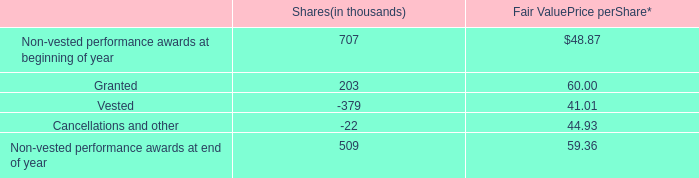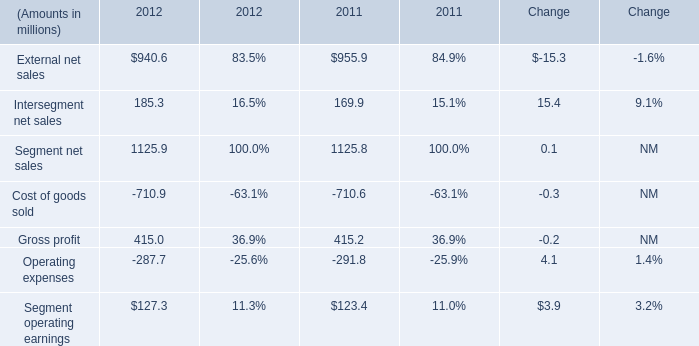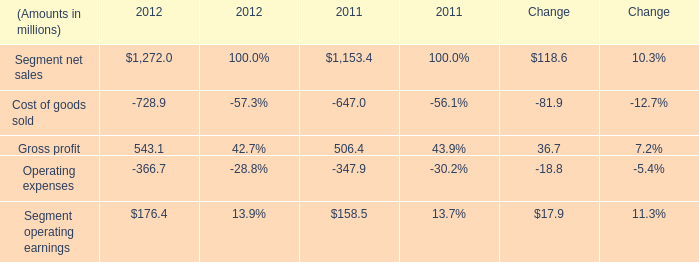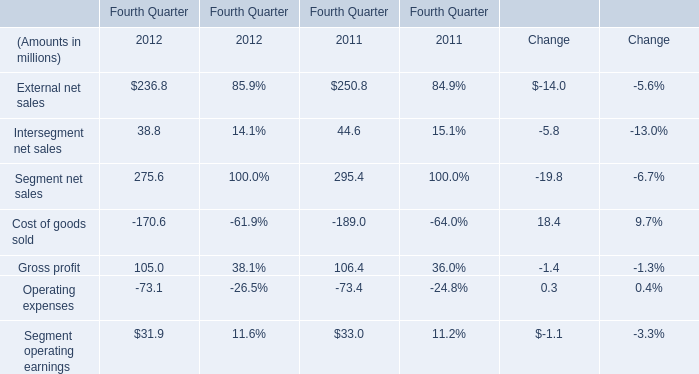What's the average of the External net sales in the years where Gross profit is positive? (in million) 
Computations: ((940.6 + 955.9) / 2)
Answer: 948.25. 